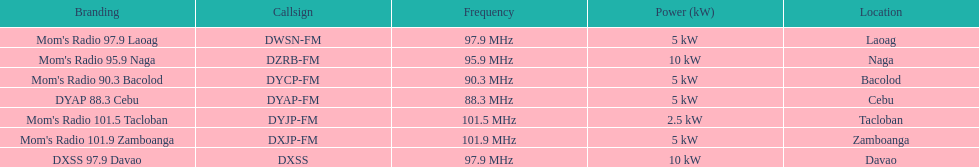Could you parse the entire table as a dict? {'header': ['Branding', 'Callsign', 'Frequency', 'Power (kW)', 'Location'], 'rows': [["Mom's Radio 97.9 Laoag", 'DWSN-FM', '97.9\xa0MHz', '5\xa0kW', 'Laoag'], ["Mom's Radio 95.9 Naga", 'DZRB-FM', '95.9\xa0MHz', '10\xa0kW', 'Naga'], ["Mom's Radio 90.3 Bacolod", 'DYCP-FM', '90.3\xa0MHz', '5\xa0kW', 'Bacolod'], ['DYAP 88.3 Cebu', 'DYAP-FM', '88.3\xa0MHz', '5\xa0kW', 'Cebu'], ["Mom's Radio 101.5 Tacloban", 'DYJP-FM', '101.5\xa0MHz', '2.5\xa0kW', 'Tacloban'], ["Mom's Radio 101.9 Zamboanga", 'DXJP-FM', '101.9\xa0MHz', '5\xa0kW', 'Zamboanga'], ['DXSS 97.9 Davao', 'DXSS', '97.9\xa0MHz', '10\xa0kW', 'Davao']]} In the power column, how many stations display 5 kw or greater? 6. 